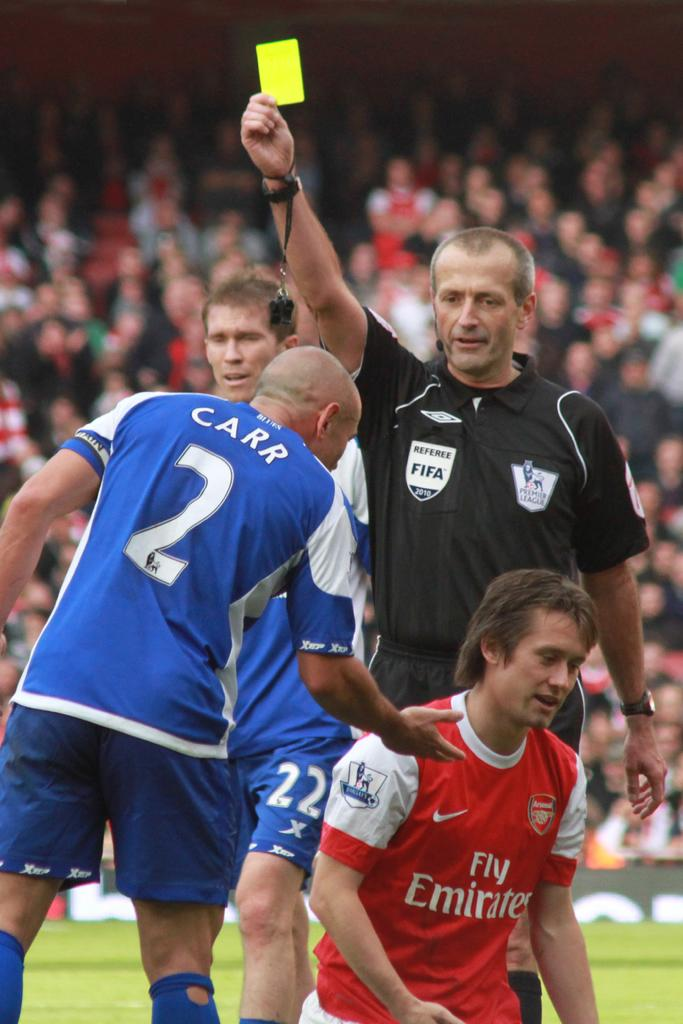<image>
Share a concise interpretation of the image provided. A player named Carr discusses something with a player in a Fly Emirates uniform. 